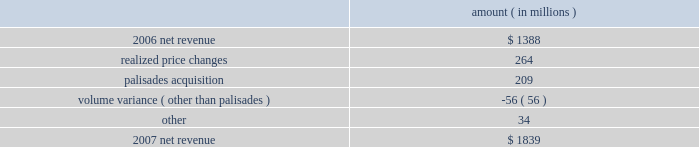Entergy corporation and subsidiaries management's financial discussion and analysis the retail electric price variance resulted from rate increases primarily at entergy louisiana effective september 2006 for the 2005 formula rate plan filing to recover lpsc-approved incremental deferred and ongoing purchased power capacity costs .
The formula rate plan filing is discussed in note 2 to the financial statements .
The volume/weather variance resulted primarily from increased electricity usage in the residential and commercial sectors , including increased usage during the unbilled sales period .
Billed retail electricity usage increased by a total of 1591 gwh , an increase of 1.6% ( 1.6 % ) .
See "critical accounting estimates" herein and note 1 to the financial statements for a discussion of the accounting for unbilled revenues .
The fuel recovery variance is primarily due to the inclusion of grand gulf costs in entergy new orleans' fuel recoveries effective july 1 , 2006 .
In june 2006 , the city council approved the recovery of grand gulf costs through the fuel adjustment clause , without a corresponding change in base rates ( a significant portion of grand gulf costs was previously recovered through base rates ) .
The increase is also due to purchased power costs deferred at entergy louisiana and entergy new orleans as a result of the re-pricing , retroactive to 2003 , of purchased power agreements among entergy system companies as directed by the ferc .
The transmission revenue variance is due to higher rates and the addition of new transmission customers in late-2006 .
The purchased power capacity variance is due to higher capacity charges and new purchased power contracts that began in mid-2006 .
A portion of the variance is due to the amortization of deferred capacity costs and is offset in base revenues due to base rate increases implemented to recover incremental deferred and ongoing purchased power capacity charges at entergy louisiana , as discussed above .
The net wholesale revenue variance is due primarily to 1 ) more energy available for resale at entergy new orleans in 2006 due to the decrease in retail usage caused by customer losses following hurricane katrina and 2 ) the inclusion in 2006 revenue of sales into the wholesale market of entergy new orleans' share of the output of grand gulf , pursuant to city council approval of measures proposed by entergy new orleans to address the reduction in entergy new orleans' retail customer usage caused by hurricane katrina and to provide revenue support for the costs of entergy new orleans' share of grand gulf .
The net wholesale revenue variance is partially offset by the effect of lower wholesale revenues in the third quarter 2006 due to an october 2006 ferc order requiring entergy arkansas to make a refund to a coal plant co-owner resulting from a contract dispute .
Non-utility nuclear following is an analysis of the change in net revenue comparing 2007 to 2006 .
Amount ( in millions ) .
As shown in the table above , net revenue increased for non-utility nuclear by $ 451 million , or 33% ( 33 % ) , for 2007 compared to 2006 primarily due to higher pricing in its contracts to sell power and additional production available resulting from the acquisition of the palisades plant in april 2007 .
Included in the palisades net revenue is $ 50 million of amortization of the palisades purchased power agreement in 2007 , which is non-cash revenue and is discussed in note 15 to the financial statements .
The increase was partially offset by the effect on revenues of four .
What percent of 2007 net revenue did the amortization of purchase power account for? 
Computations: (50 / 1839)
Answer: 0.02719. 